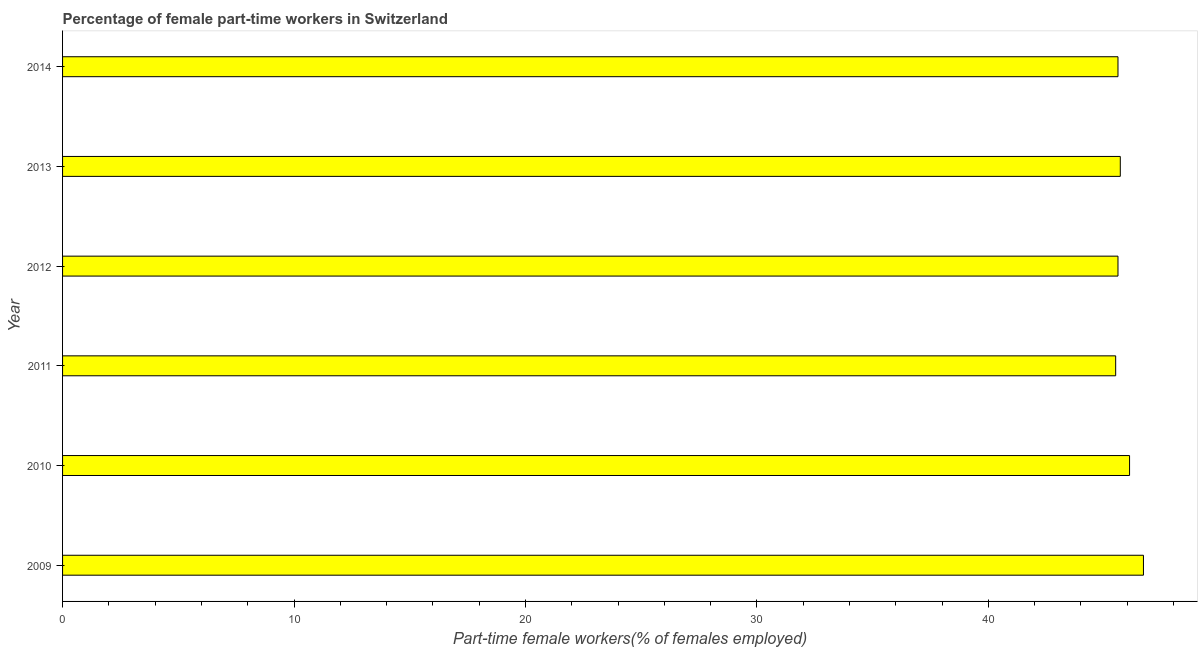Does the graph contain any zero values?
Give a very brief answer. No. What is the title of the graph?
Your response must be concise. Percentage of female part-time workers in Switzerland. What is the label or title of the X-axis?
Your answer should be compact. Part-time female workers(% of females employed). What is the label or title of the Y-axis?
Your response must be concise. Year. What is the percentage of part-time female workers in 2009?
Keep it short and to the point. 46.7. Across all years, what is the maximum percentage of part-time female workers?
Your answer should be compact. 46.7. Across all years, what is the minimum percentage of part-time female workers?
Keep it short and to the point. 45.5. In which year was the percentage of part-time female workers minimum?
Give a very brief answer. 2011. What is the sum of the percentage of part-time female workers?
Offer a very short reply. 275.2. What is the difference between the percentage of part-time female workers in 2011 and 2013?
Keep it short and to the point. -0.2. What is the average percentage of part-time female workers per year?
Provide a succinct answer. 45.87. What is the median percentage of part-time female workers?
Your answer should be compact. 45.65. What is the difference between the highest and the lowest percentage of part-time female workers?
Make the answer very short. 1.2. In how many years, is the percentage of part-time female workers greater than the average percentage of part-time female workers taken over all years?
Offer a very short reply. 2. How many years are there in the graph?
Keep it short and to the point. 6. Are the values on the major ticks of X-axis written in scientific E-notation?
Your response must be concise. No. What is the Part-time female workers(% of females employed) of 2009?
Ensure brevity in your answer.  46.7. What is the Part-time female workers(% of females employed) in 2010?
Give a very brief answer. 46.1. What is the Part-time female workers(% of females employed) of 2011?
Your answer should be very brief. 45.5. What is the Part-time female workers(% of females employed) in 2012?
Your response must be concise. 45.6. What is the Part-time female workers(% of females employed) in 2013?
Provide a succinct answer. 45.7. What is the Part-time female workers(% of females employed) in 2014?
Offer a very short reply. 45.6. What is the difference between the Part-time female workers(% of females employed) in 2009 and 2010?
Provide a succinct answer. 0.6. What is the difference between the Part-time female workers(% of females employed) in 2009 and 2012?
Keep it short and to the point. 1.1. What is the difference between the Part-time female workers(% of females employed) in 2010 and 2011?
Your answer should be very brief. 0.6. What is the difference between the Part-time female workers(% of females employed) in 2010 and 2012?
Give a very brief answer. 0.5. What is the difference between the Part-time female workers(% of females employed) in 2011 and 2013?
Your answer should be compact. -0.2. What is the difference between the Part-time female workers(% of females employed) in 2012 and 2013?
Offer a terse response. -0.1. What is the ratio of the Part-time female workers(% of females employed) in 2009 to that in 2010?
Keep it short and to the point. 1.01. What is the ratio of the Part-time female workers(% of females employed) in 2009 to that in 2014?
Your response must be concise. 1.02. What is the ratio of the Part-time female workers(% of females employed) in 2010 to that in 2012?
Keep it short and to the point. 1.01. What is the ratio of the Part-time female workers(% of females employed) in 2011 to that in 2012?
Ensure brevity in your answer.  1. What is the ratio of the Part-time female workers(% of females employed) in 2012 to that in 2013?
Offer a very short reply. 1. 